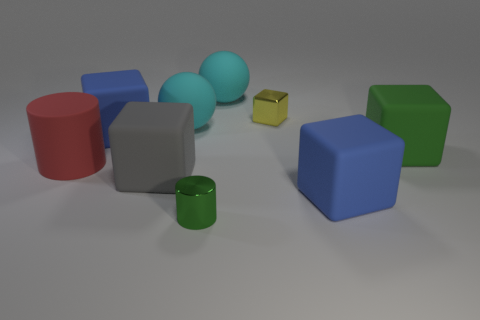Is the number of tiny cylinders greater than the number of blue rubber balls?
Your answer should be very brief. Yes. How many metal objects are green cubes or small gray cubes?
Offer a very short reply. 0. How many shiny blocks have the same color as the large cylinder?
Your answer should be very brief. 0. What material is the cube that is behind the blue matte object behind the big blue rubber block that is on the right side of the green shiny cylinder?
Keep it short and to the point. Metal. The rubber ball right of the cyan rubber ball that is in front of the metallic cube is what color?
Keep it short and to the point. Cyan. What number of small objects are cyan rubber balls or green rubber cylinders?
Offer a terse response. 0. What number of purple cubes are the same material as the green block?
Make the answer very short. 0. How big is the blue block that is on the right side of the tiny green metal cylinder?
Provide a succinct answer. Large. There is a tiny thing behind the cyan rubber ball that is in front of the small yellow shiny object; what is its shape?
Provide a succinct answer. Cube. There is a big blue rubber block behind the large matte cylinder that is to the left of the metal cylinder; how many cyan rubber spheres are in front of it?
Provide a succinct answer. 0. 